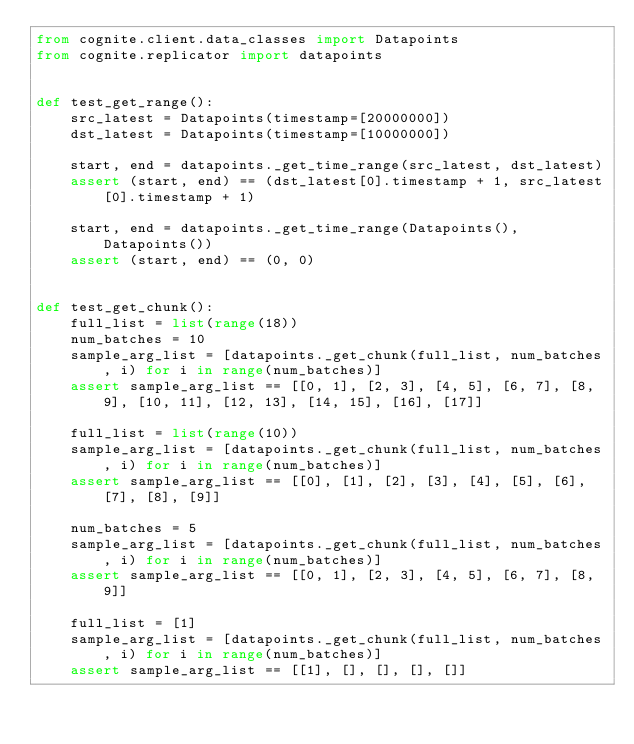<code> <loc_0><loc_0><loc_500><loc_500><_Python_>from cognite.client.data_classes import Datapoints
from cognite.replicator import datapoints


def test_get_range():
    src_latest = Datapoints(timestamp=[20000000])
    dst_latest = Datapoints(timestamp=[10000000])

    start, end = datapoints._get_time_range(src_latest, dst_latest)
    assert (start, end) == (dst_latest[0].timestamp + 1, src_latest[0].timestamp + 1)

    start, end = datapoints._get_time_range(Datapoints(), Datapoints())
    assert (start, end) == (0, 0)


def test_get_chunk():
    full_list = list(range(18))
    num_batches = 10
    sample_arg_list = [datapoints._get_chunk(full_list, num_batches, i) for i in range(num_batches)]
    assert sample_arg_list == [[0, 1], [2, 3], [4, 5], [6, 7], [8, 9], [10, 11], [12, 13], [14, 15], [16], [17]]

    full_list = list(range(10))
    sample_arg_list = [datapoints._get_chunk(full_list, num_batches, i) for i in range(num_batches)]
    assert sample_arg_list == [[0], [1], [2], [3], [4], [5], [6], [7], [8], [9]]

    num_batches = 5
    sample_arg_list = [datapoints._get_chunk(full_list, num_batches, i) for i in range(num_batches)]
    assert sample_arg_list == [[0, 1], [2, 3], [4, 5], [6, 7], [8, 9]]

    full_list = [1]
    sample_arg_list = [datapoints._get_chunk(full_list, num_batches, i) for i in range(num_batches)]
    assert sample_arg_list == [[1], [], [], [], []]
</code> 